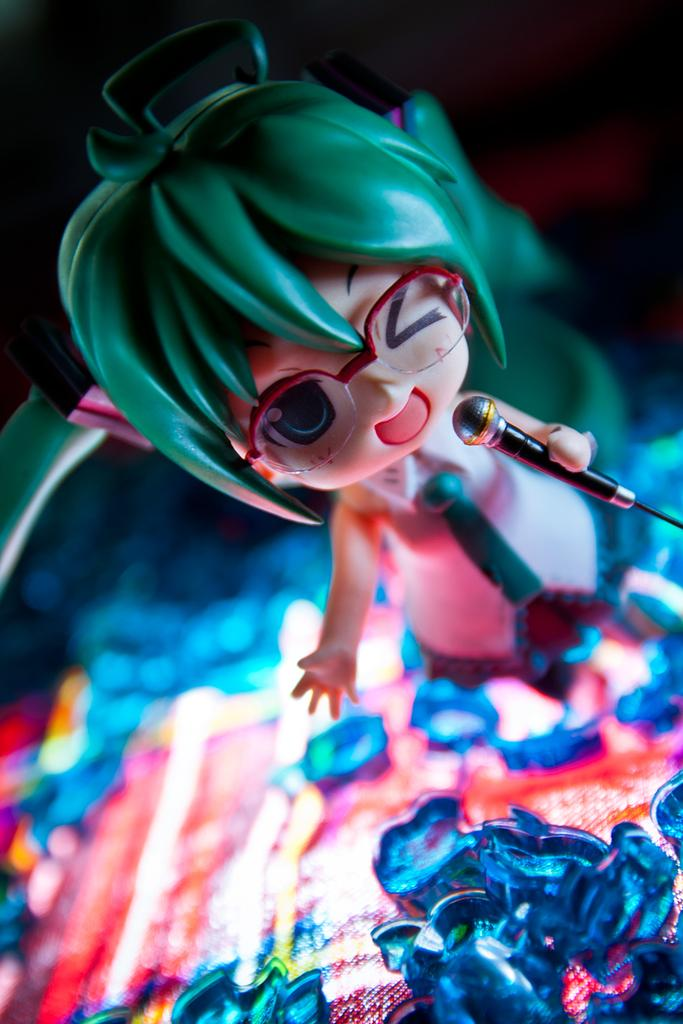What is the main subject of the image? There is a toy in the image. Can you describe any other objects in the image? Yes, there are some objects in the image. What can be observed about the background of the image? The background of the image is blurred. What type of cabbage can be smelled in the image? There is no cabbage present in the image, and therefore no scent can be detected. 